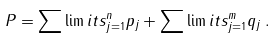Convert formula to latex. <formula><loc_0><loc_0><loc_500><loc_500>P = \sum \lim i t s _ { j = 1 } ^ { n } p _ { j } + \sum \lim i t s _ { j = 1 } ^ { m } q _ { j } \, .</formula> 